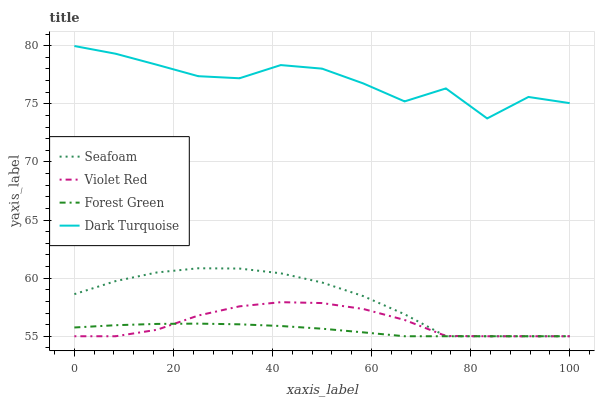Does Forest Green have the minimum area under the curve?
Answer yes or no. Yes. Does Dark Turquoise have the maximum area under the curve?
Answer yes or no. Yes. Does Violet Red have the minimum area under the curve?
Answer yes or no. No. Does Violet Red have the maximum area under the curve?
Answer yes or no. No. Is Forest Green the smoothest?
Answer yes or no. Yes. Is Dark Turquoise the roughest?
Answer yes or no. Yes. Is Violet Red the smoothest?
Answer yes or no. No. Is Violet Red the roughest?
Answer yes or no. No. Does Forest Green have the lowest value?
Answer yes or no. Yes. Does Dark Turquoise have the lowest value?
Answer yes or no. No. Does Dark Turquoise have the highest value?
Answer yes or no. Yes. Does Violet Red have the highest value?
Answer yes or no. No. Is Forest Green less than Dark Turquoise?
Answer yes or no. Yes. Is Dark Turquoise greater than Forest Green?
Answer yes or no. Yes. Does Seafoam intersect Violet Red?
Answer yes or no. Yes. Is Seafoam less than Violet Red?
Answer yes or no. No. Is Seafoam greater than Violet Red?
Answer yes or no. No. Does Forest Green intersect Dark Turquoise?
Answer yes or no. No. 